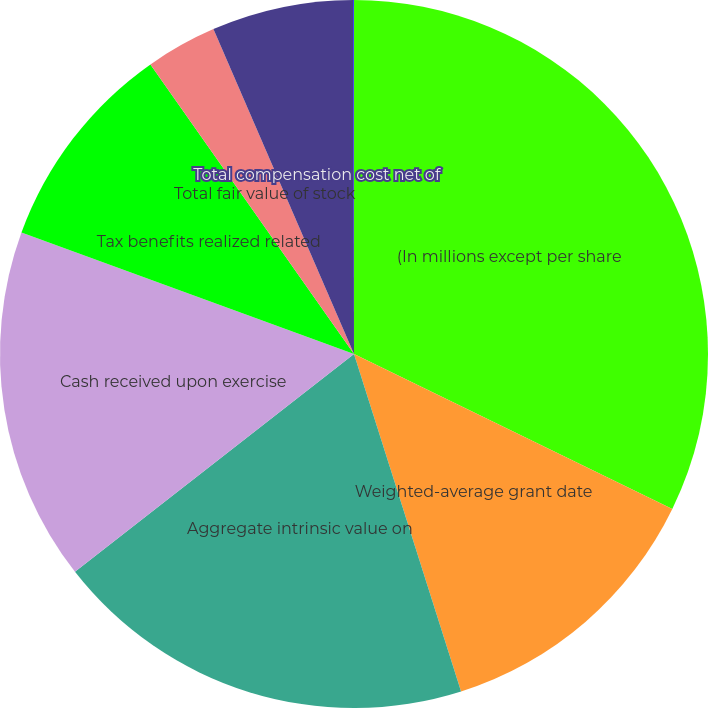Convert chart to OTSL. <chart><loc_0><loc_0><loc_500><loc_500><pie_chart><fcel>(In millions except per share<fcel>Weighted-average grant date<fcel>Aggregate intrinsic value on<fcel>Cash received upon exercise<fcel>Tax benefits realized related<fcel>Total fair value of stock<fcel>Total compensation cost net of<fcel>Weighted-average period in<nl><fcel>32.21%<fcel>12.9%<fcel>19.34%<fcel>16.12%<fcel>9.68%<fcel>3.25%<fcel>6.47%<fcel>0.03%<nl></chart> 